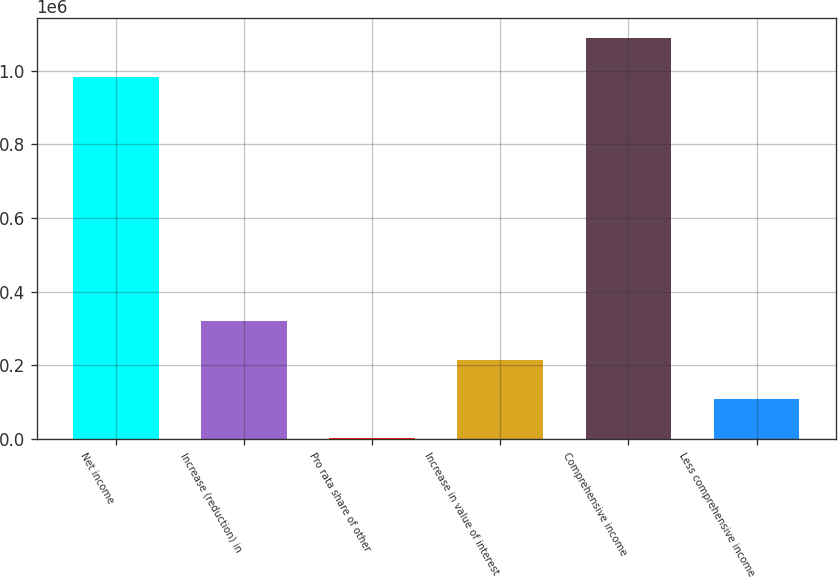Convert chart. <chart><loc_0><loc_0><loc_500><loc_500><bar_chart><fcel>Net income<fcel>Increase (reduction) in<fcel>Pro rata share of other<fcel>Increase in value of interest<fcel>Comprehensive income<fcel>Less comprehensive income<nl><fcel>981922<fcel>319519<fcel>2739<fcel>213926<fcel>1.08752e+06<fcel>108332<nl></chart> 